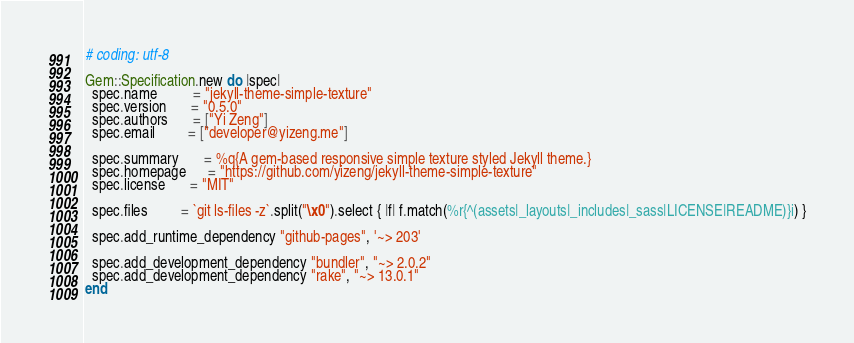Convert code to text. <code><loc_0><loc_0><loc_500><loc_500><_Ruby_># coding: utf-8

Gem::Specification.new do |spec|
  spec.name          = "jekyll-theme-simple-texture"
  spec.version       = "0.5.0"
  spec.authors       = ["Yi Zeng"]
  spec.email         = ["developer@yizeng.me"]

  spec.summary       = %q{A gem-based responsive simple texture styled Jekyll theme.}
  spec.homepage      = "https://github.com/yizeng/jekyll-theme-simple-texture"
  spec.license       = "MIT"

  spec.files         = `git ls-files -z`.split("\x0").select { |f| f.match(%r{^(assets|_layouts|_includes|_sass|LICENSE|README)}i) }

  spec.add_runtime_dependency "github-pages", '~> 203'

  spec.add_development_dependency "bundler", "~> 2.0.2"
  spec.add_development_dependency "rake", "~> 13.0.1"
end
</code> 